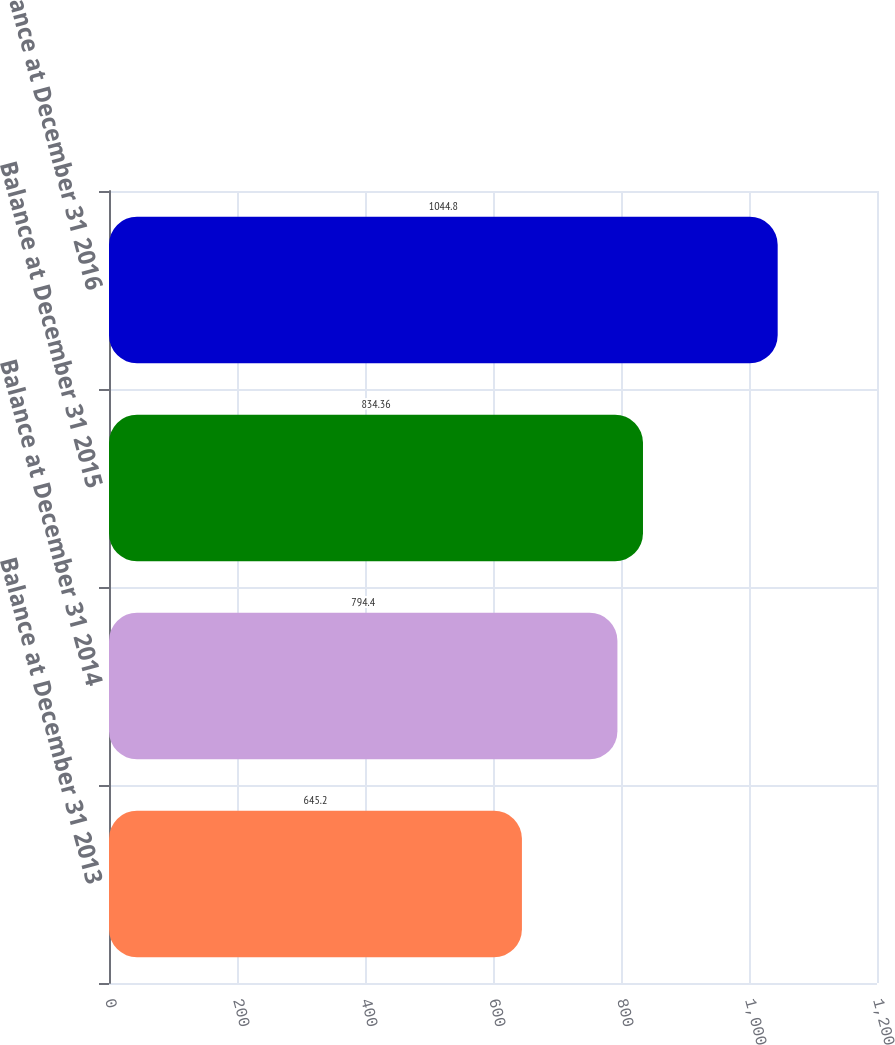<chart> <loc_0><loc_0><loc_500><loc_500><bar_chart><fcel>Balance at December 31 2013<fcel>Balance at December 31 2014<fcel>Balance at December 31 2015<fcel>Balance at December 31 2016<nl><fcel>645.2<fcel>794.4<fcel>834.36<fcel>1044.8<nl></chart> 